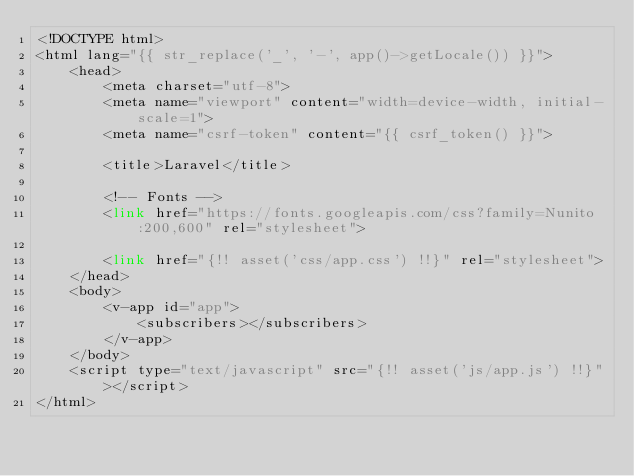<code> <loc_0><loc_0><loc_500><loc_500><_PHP_><!DOCTYPE html>
<html lang="{{ str_replace('_', '-', app()->getLocale()) }}">
    <head>
        <meta charset="utf-8">
        <meta name="viewport" content="width=device-width, initial-scale=1">
        <meta name="csrf-token" content="{{ csrf_token() }}">

        <title>Laravel</title>

        <!-- Fonts -->
        <link href="https://fonts.googleapis.com/css?family=Nunito:200,600" rel="stylesheet">

        <link href="{!! asset('css/app.css') !!}" rel="stylesheet">
    </head>
    <body>
        <v-app id="app">
            <subscribers></subscribers>
        </v-app>
    </body>
    <script type="text/javascript" src="{!! asset('js/app.js') !!}"></script>
</html>
</code> 